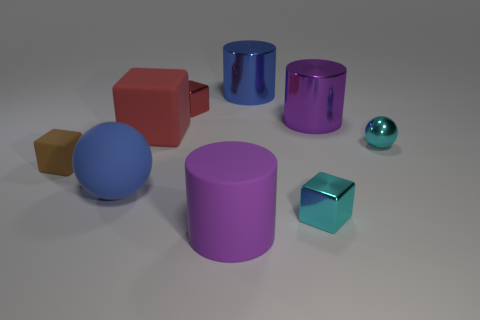There is a shiny object that is the same color as the large matte block; what is its size?
Your answer should be compact. Small. What is the size of the purple cylinder that is the same material as the small cyan sphere?
Your response must be concise. Large. There is a thing that is the same color as the big matte block; what is its shape?
Your response must be concise. Cube. Is there any other thing that has the same color as the matte cylinder?
Offer a terse response. Yes. There is a red rubber thing; is it the same shape as the small cyan thing in front of the brown rubber cube?
Ensure brevity in your answer.  Yes. What material is the thing on the right side of the purple cylinder that is right of the tiny cyan metal thing in front of the tiny brown rubber thing?
Keep it short and to the point. Metal. What number of other things are there of the same size as the blue sphere?
Make the answer very short. 4. There is a large shiny thing that is in front of the tiny thing that is behind the cyan shiny sphere; what number of large purple metallic cylinders are to the left of it?
Keep it short and to the point. 0. There is a large purple cylinder behind the block that is on the left side of the blue ball; what is its material?
Your answer should be compact. Metal. Is there another rubber thing that has the same shape as the small red thing?
Provide a short and direct response. Yes. 